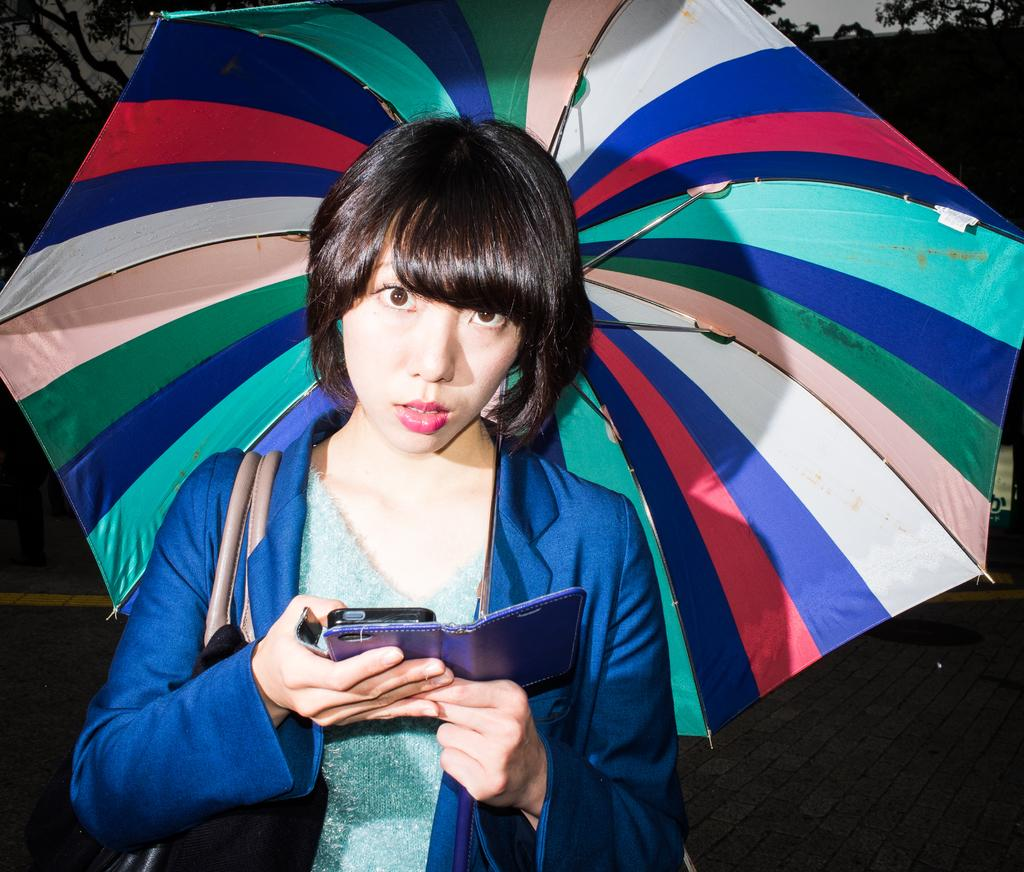Who is the main subject in the image? There is a woman in the image. What is the woman doing in the image? The woman is operating a mobile phone. What object is the woman holding in the image? The woman is holding a colorful umbrella. What type of surface is the woman standing on in the image? The woman is standing on a wooden surface. What type of wire is visible in the image? There is no wire visible in the image. How many pieces of waste can be seen in the image? There is no waste present in the image. 